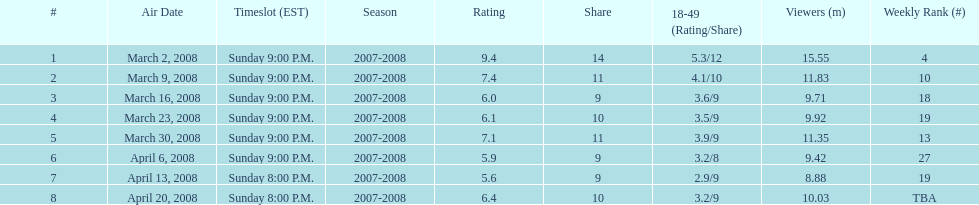Which series received the highest score? 1. 